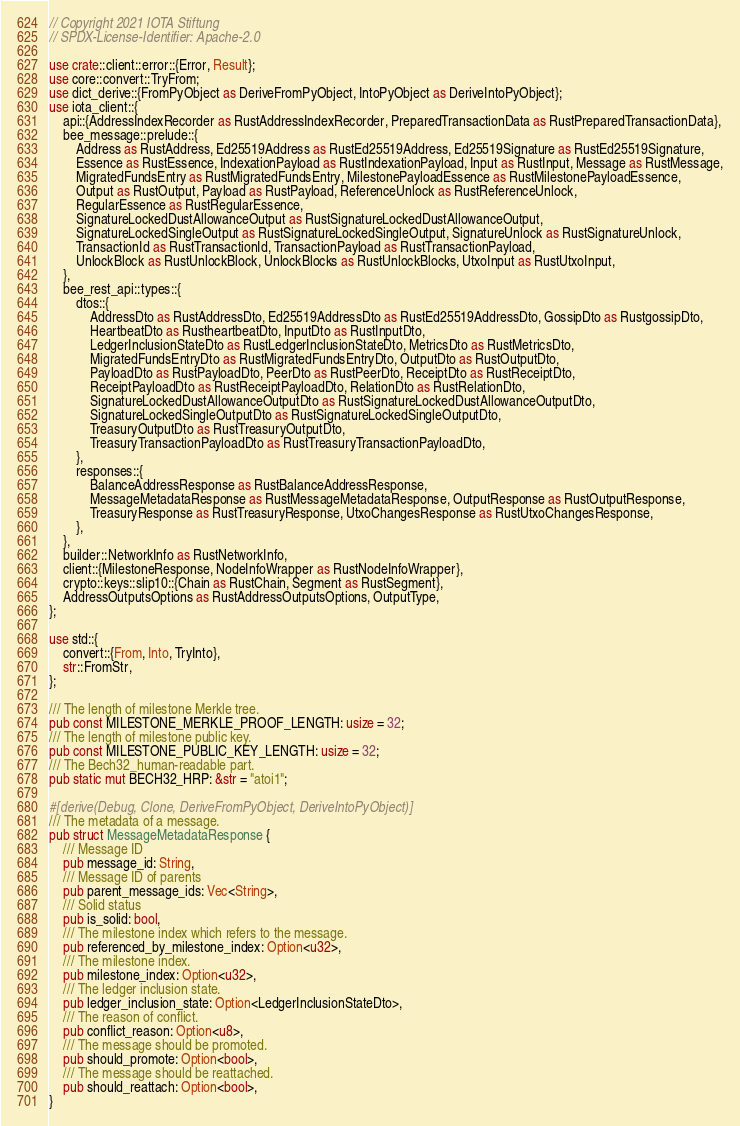<code> <loc_0><loc_0><loc_500><loc_500><_Rust_>// Copyright 2021 IOTA Stiftung
// SPDX-License-Identifier: Apache-2.0

use crate::client::error::{Error, Result};
use core::convert::TryFrom;
use dict_derive::{FromPyObject as DeriveFromPyObject, IntoPyObject as DeriveIntoPyObject};
use iota_client::{
    api::{AddressIndexRecorder as RustAddressIndexRecorder, PreparedTransactionData as RustPreparedTransactionData},
    bee_message::prelude::{
        Address as RustAddress, Ed25519Address as RustEd25519Address, Ed25519Signature as RustEd25519Signature,
        Essence as RustEssence, IndexationPayload as RustIndexationPayload, Input as RustInput, Message as RustMessage,
        MigratedFundsEntry as RustMigratedFundsEntry, MilestonePayloadEssence as RustMilestonePayloadEssence,
        Output as RustOutput, Payload as RustPayload, ReferenceUnlock as RustReferenceUnlock,
        RegularEssence as RustRegularEssence,
        SignatureLockedDustAllowanceOutput as RustSignatureLockedDustAllowanceOutput,
        SignatureLockedSingleOutput as RustSignatureLockedSingleOutput, SignatureUnlock as RustSignatureUnlock,
        TransactionId as RustTransactionId, TransactionPayload as RustTransactionPayload,
        UnlockBlock as RustUnlockBlock, UnlockBlocks as RustUnlockBlocks, UtxoInput as RustUtxoInput,
    },
    bee_rest_api::types::{
        dtos::{
            AddressDto as RustAddressDto, Ed25519AddressDto as RustEd25519AddressDto, GossipDto as RustgossipDto,
            HeartbeatDto as RustheartbeatDto, InputDto as RustInputDto,
            LedgerInclusionStateDto as RustLedgerInclusionStateDto, MetricsDto as RustMetricsDto,
            MigratedFundsEntryDto as RustMigratedFundsEntryDto, OutputDto as RustOutputDto,
            PayloadDto as RustPayloadDto, PeerDto as RustPeerDto, ReceiptDto as RustReceiptDto,
            ReceiptPayloadDto as RustReceiptPayloadDto, RelationDto as RustRelationDto,
            SignatureLockedDustAllowanceOutputDto as RustSignatureLockedDustAllowanceOutputDto,
            SignatureLockedSingleOutputDto as RustSignatureLockedSingleOutputDto,
            TreasuryOutputDto as RustTreasuryOutputDto,
            TreasuryTransactionPayloadDto as RustTreasuryTransactionPayloadDto,
        },
        responses::{
            BalanceAddressResponse as RustBalanceAddressResponse,
            MessageMetadataResponse as RustMessageMetadataResponse, OutputResponse as RustOutputResponse,
            TreasuryResponse as RustTreasuryResponse, UtxoChangesResponse as RustUtxoChangesResponse,
        },
    },
    builder::NetworkInfo as RustNetworkInfo,
    client::{MilestoneResponse, NodeInfoWrapper as RustNodeInfoWrapper},
    crypto::keys::slip10::{Chain as RustChain, Segment as RustSegment},
    AddressOutputsOptions as RustAddressOutputsOptions, OutputType,
};

use std::{
    convert::{From, Into, TryInto},
    str::FromStr,
};

/// The length of milestone Merkle tree.
pub const MILESTONE_MERKLE_PROOF_LENGTH: usize = 32;
/// The length of milestone public key.
pub const MILESTONE_PUBLIC_KEY_LENGTH: usize = 32;
/// The Bech32_human-readable part.
pub static mut BECH32_HRP: &str = "atoi1";

#[derive(Debug, Clone, DeriveFromPyObject, DeriveIntoPyObject)]
/// The metadata of a message.
pub struct MessageMetadataResponse {
    /// Message ID
    pub message_id: String,
    /// Message ID of parents
    pub parent_message_ids: Vec<String>,
    /// Solid status
    pub is_solid: bool,
    /// The milestone index which refers to the message.
    pub referenced_by_milestone_index: Option<u32>,
    /// The milestone index.
    pub milestone_index: Option<u32>,
    /// The ledger inclusion state.
    pub ledger_inclusion_state: Option<LedgerInclusionStateDto>,
    /// The reason of conflict.
    pub conflict_reason: Option<u8>,
    /// The message should be promoted.
    pub should_promote: Option<bool>,
    /// The message should be reattached.
    pub should_reattach: Option<bool>,
}
</code> 